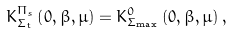Convert formula to latex. <formula><loc_0><loc_0><loc_500><loc_500>K _ { \Sigma _ { t } } ^ { \Pi _ { s } } \left ( 0 , \beta , \mu \right ) = K _ { \Sigma _ { \max } } ^ { 0 } \left ( 0 , \beta , \mu \right ) ,</formula> 